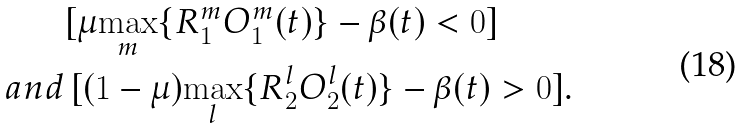Convert formula to latex. <formula><loc_0><loc_0><loc_500><loc_500>& [ \mu { \underset { m } { \max } } \{ R _ { 1 } ^ { m } O _ { 1 } ^ { m } ( t ) \} - \beta ( t ) < 0 ] \, \\ a n d & \, [ ( 1 - \mu ) { \underset { l } { \max } } \{ R _ { 2 } ^ { l } O _ { 2 } ^ { l } ( t ) \} - \beta ( t ) > 0 ] .</formula> 